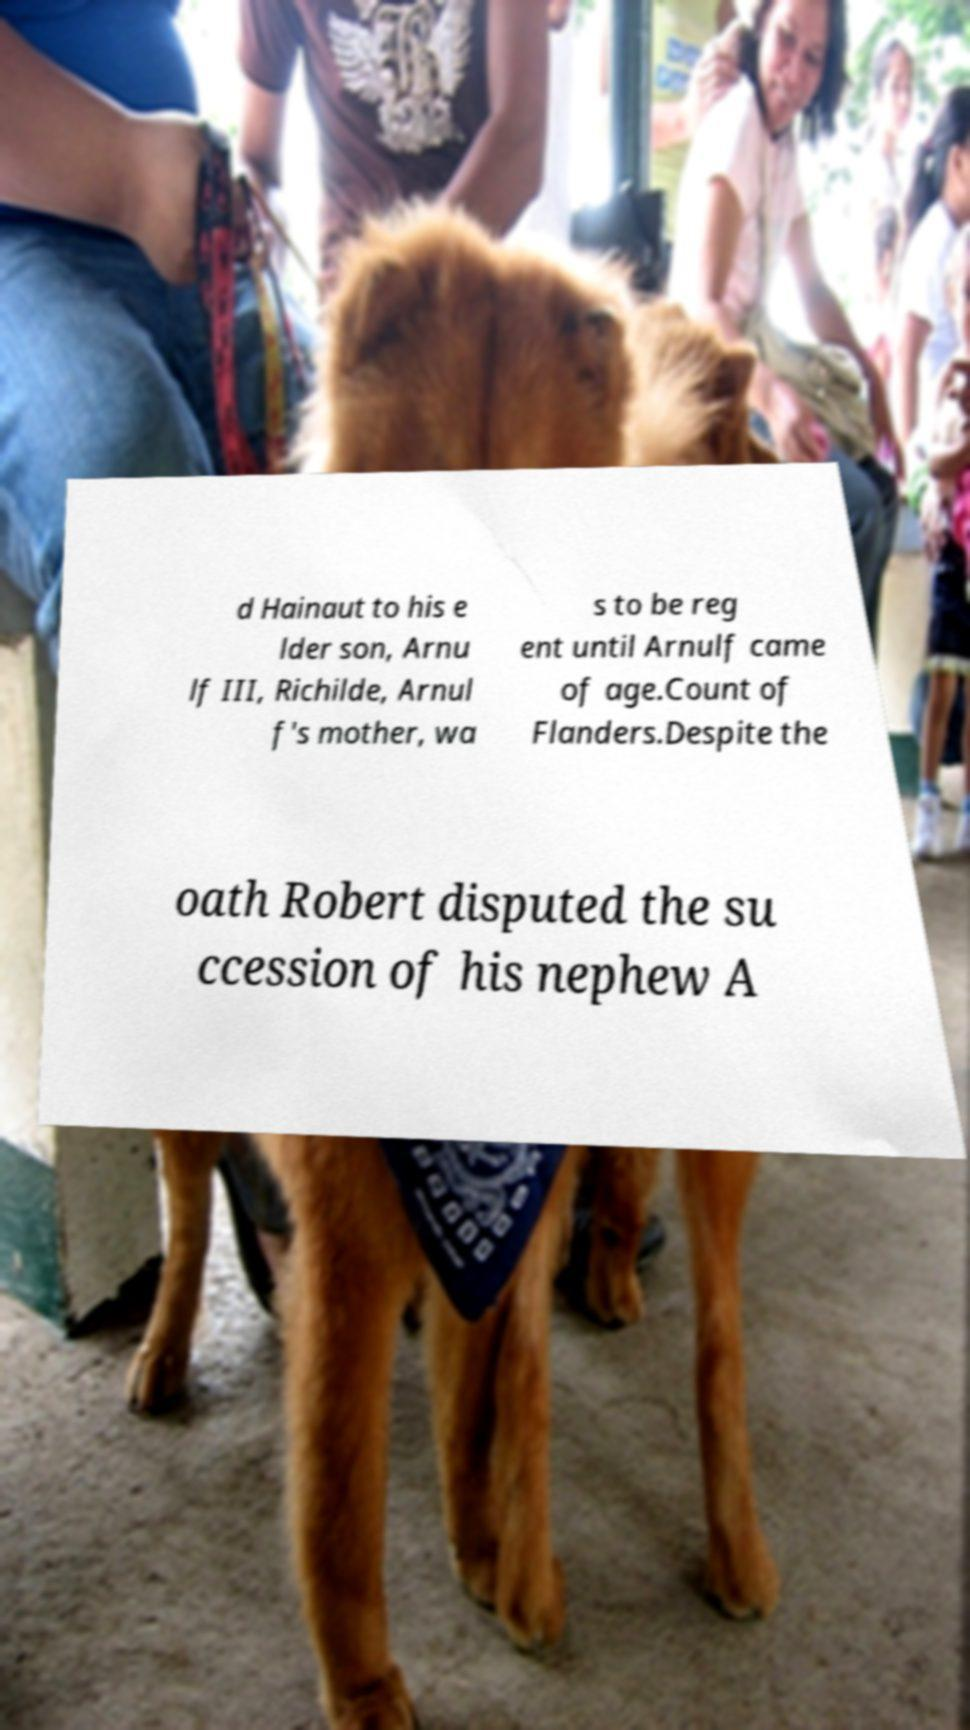Can you read and provide the text displayed in the image?This photo seems to have some interesting text. Can you extract and type it out for me? d Hainaut to his e lder son, Arnu lf III, Richilde, Arnul f's mother, wa s to be reg ent until Arnulf came of age.Count of Flanders.Despite the oath Robert disputed the su ccession of his nephew A 